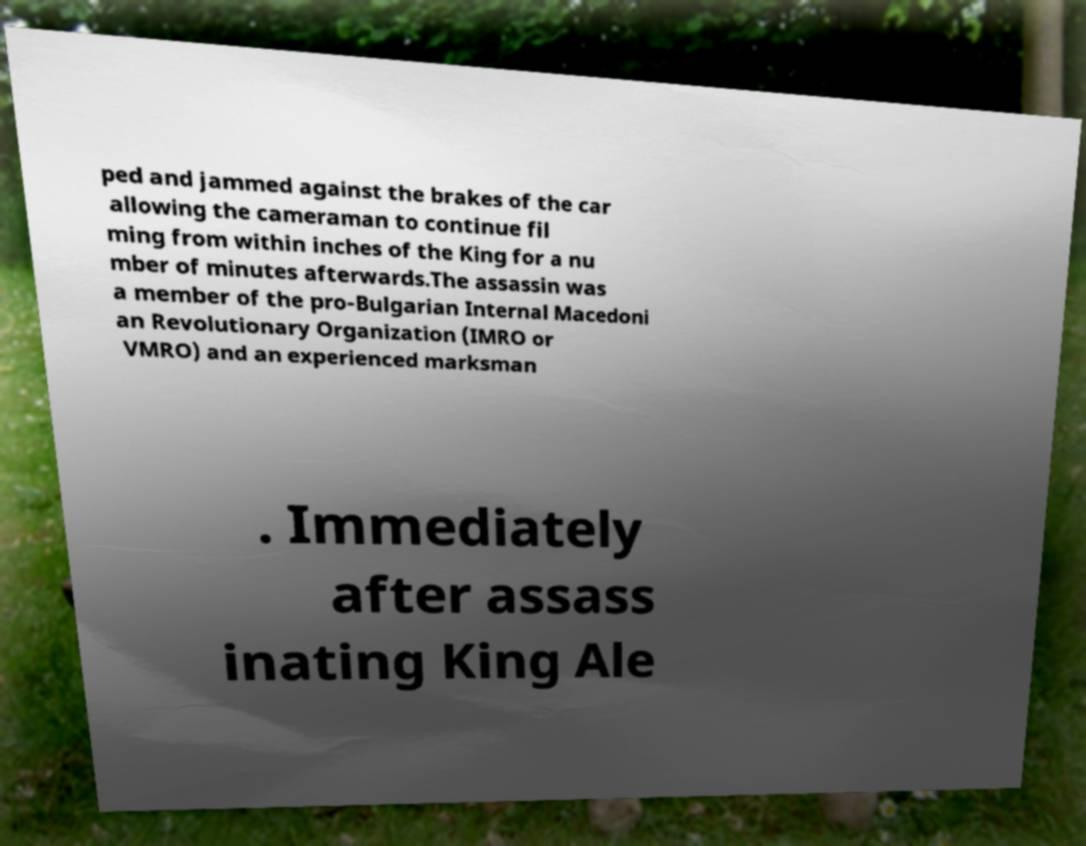Can you read and provide the text displayed in the image?This photo seems to have some interesting text. Can you extract and type it out for me? ped and jammed against the brakes of the car allowing the cameraman to continue fil ming from within inches of the King for a nu mber of minutes afterwards.The assassin was a member of the pro-Bulgarian Internal Macedoni an Revolutionary Organization (IMRO or VMRO) and an experienced marksman . Immediately after assass inating King Ale 